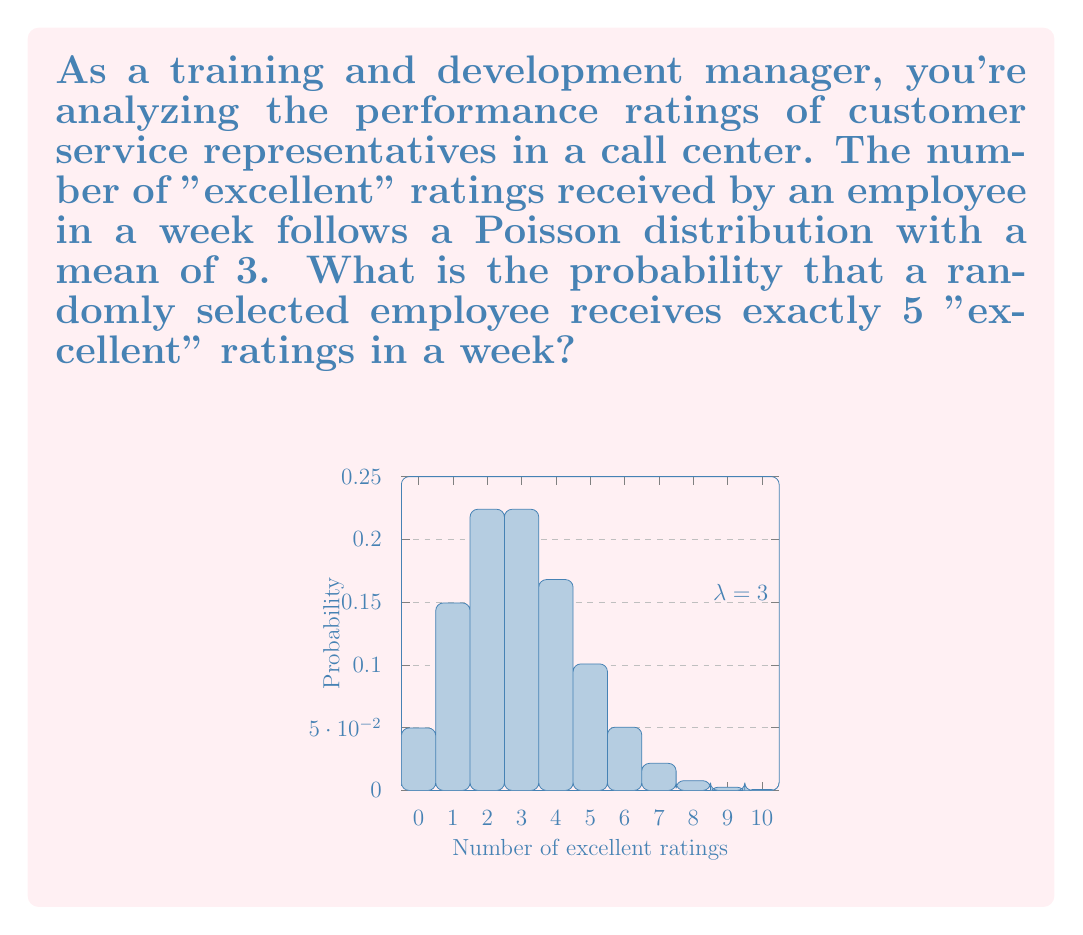Can you solve this math problem? To solve this problem, we'll use the Poisson probability mass function:

$$P(X = k) = \frac{e^{-\lambda} \lambda^k}{k!}$$

Where:
- $\lambda$ is the average rate of occurrence (mean)
- $k$ is the number of occurrences we're interested in
- $e$ is Euler's number (approximately 2.71828)

Given:
- $\lambda = 3$ (mean number of "excellent" ratings per week)
- $k = 5$ (we're interested in exactly 5 "excellent" ratings)

Step 1: Plug the values into the Poisson probability mass function:

$$P(X = 5) = \frac{e^{-3} 3^5}{5!}$$

Step 2: Calculate the numerator:
- $e^{-3} \approx 0.0497871$
- $3^5 = 243$
- $e^{-3} \cdot 3^5 \approx 12.0984$

Step 3: Calculate the denominator:
- $5! = 5 \times 4 \times 3 \times 2 \times 1 = 120$

Step 4: Divide the numerator by the denominator:

$$P(X = 5) = \frac{12.0984}{120} \approx 0.1008$$

Therefore, the probability of a randomly selected employee receiving exactly 5 "excellent" ratings in a week is approximately 0.1008 or 10.08%.
Answer: 0.1008 (or 10.08%) 